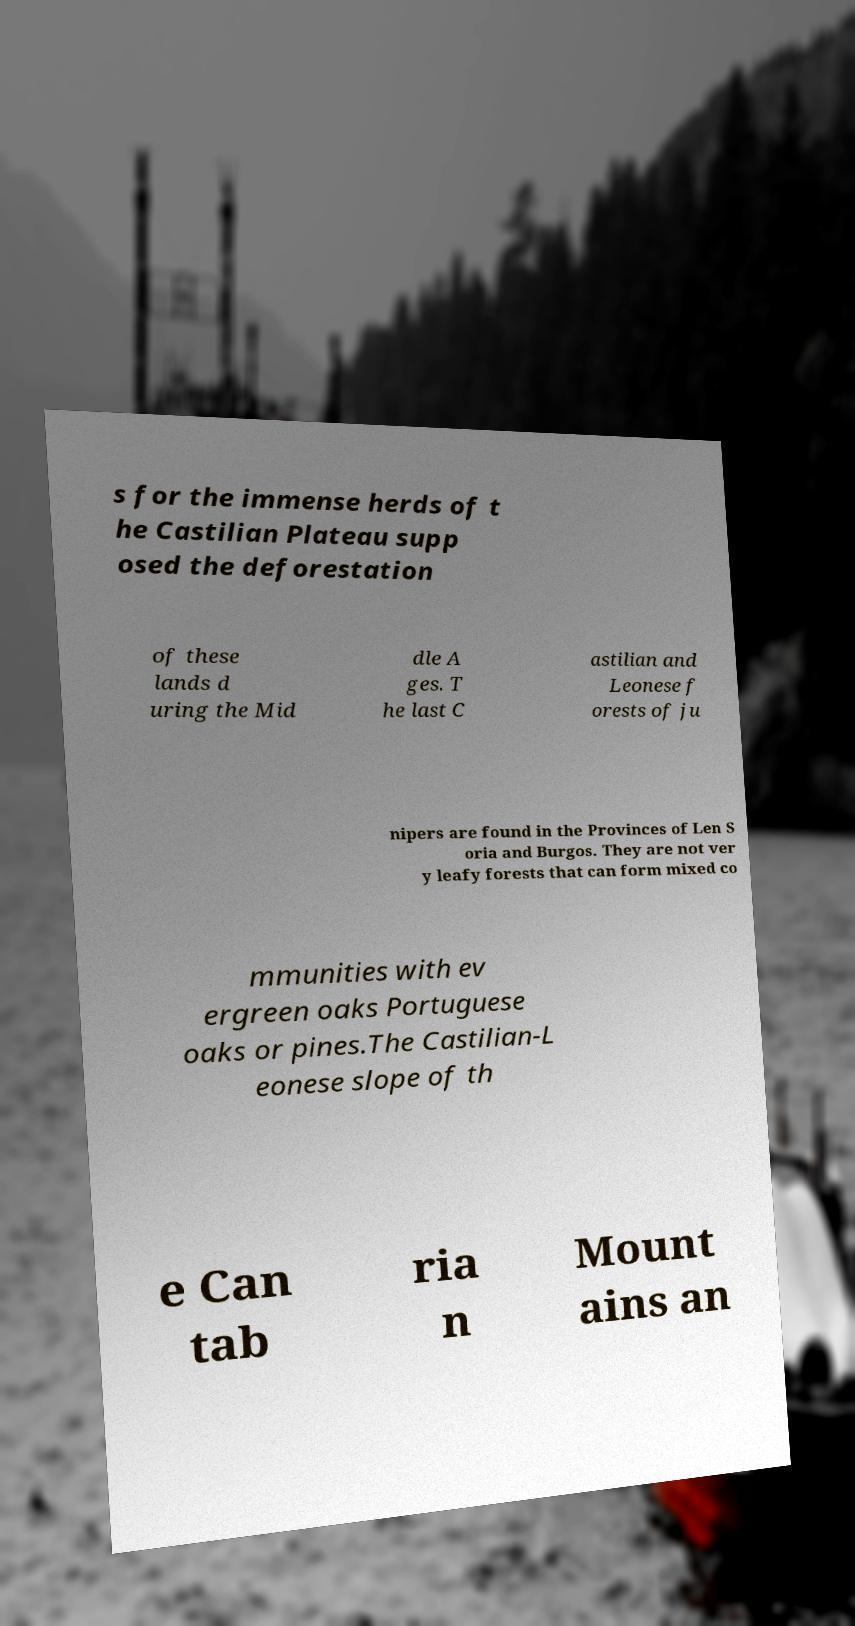Could you assist in decoding the text presented in this image and type it out clearly? s for the immense herds of t he Castilian Plateau supp osed the deforestation of these lands d uring the Mid dle A ges. T he last C astilian and Leonese f orests of ju nipers are found in the Provinces of Len S oria and Burgos. They are not ver y leafy forests that can form mixed co mmunities with ev ergreen oaks Portuguese oaks or pines.The Castilian-L eonese slope of th e Can tab ria n Mount ains an 